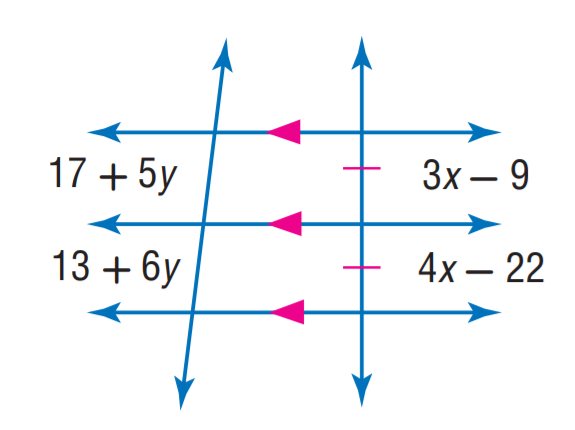Answer the mathemtical geometry problem and directly provide the correct option letter.
Question: Find x.
Choices: A: 9 B: 13 C: 16 D: 22 B 